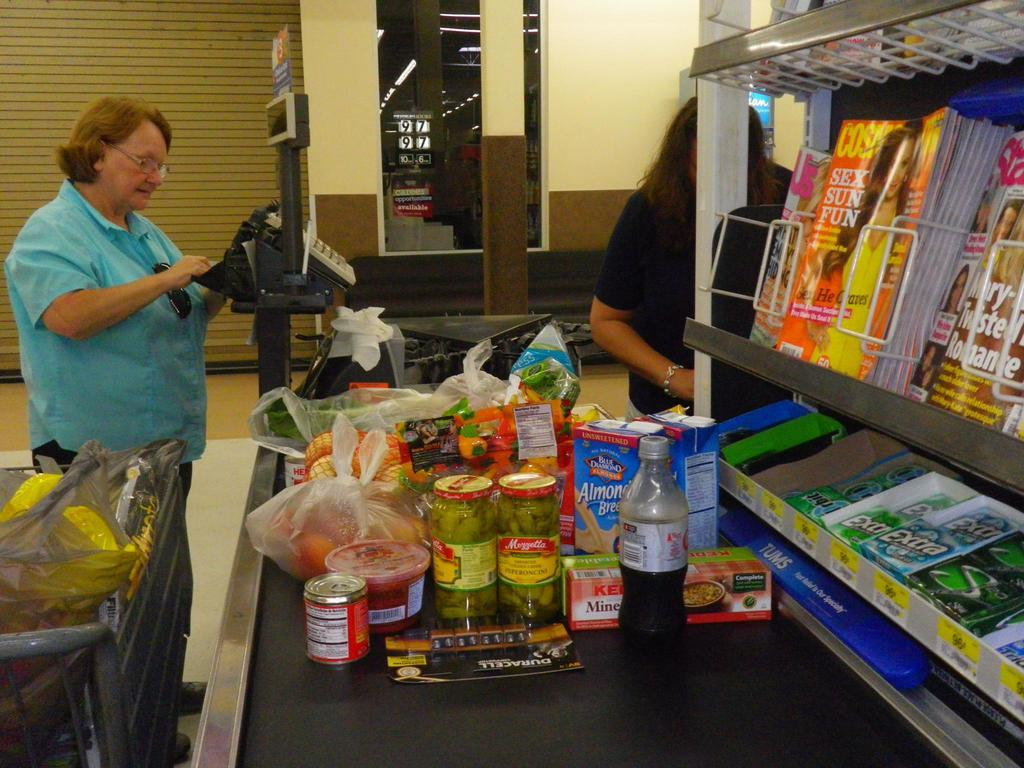<image>
Give a short and clear explanation of the subsequent image. Check out lane with a magazine display featuring Cosmopolitan. 